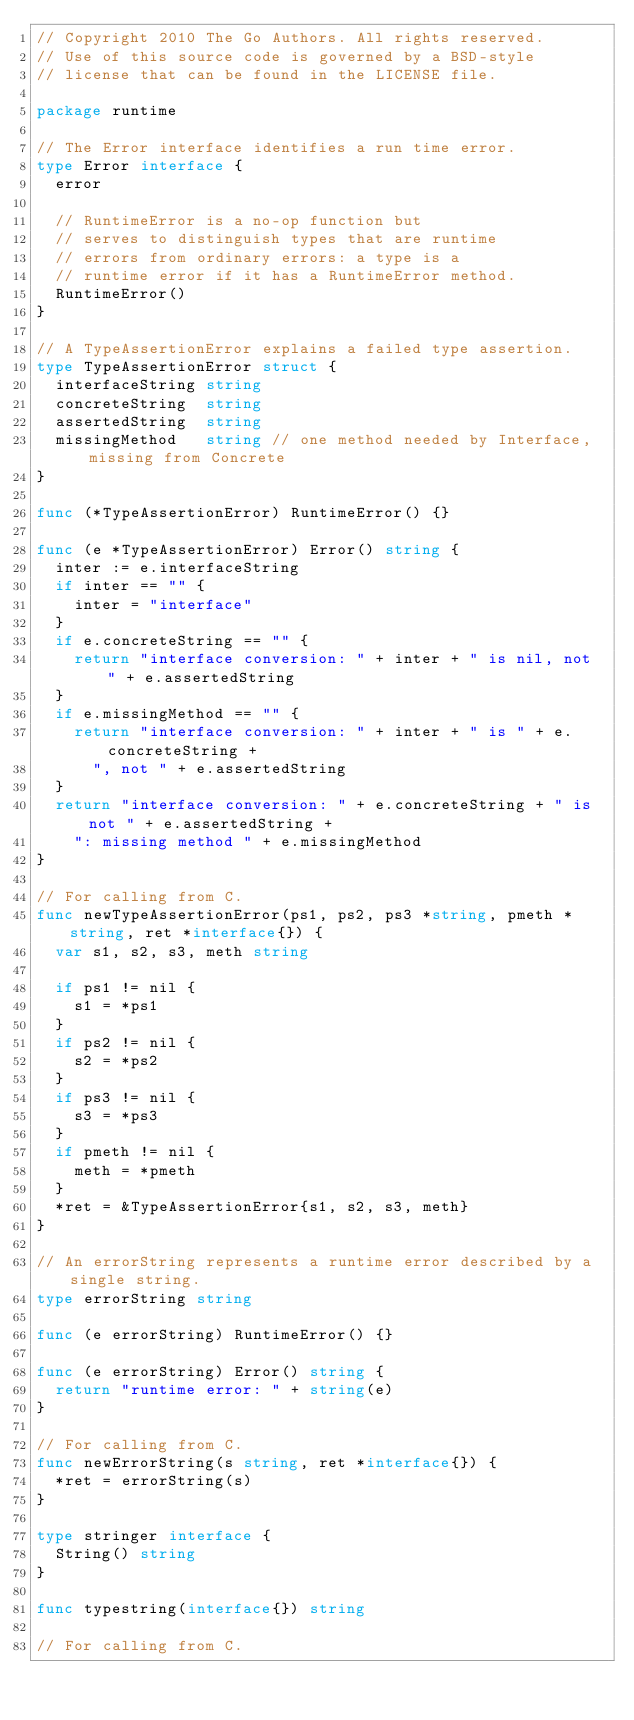<code> <loc_0><loc_0><loc_500><loc_500><_Go_>// Copyright 2010 The Go Authors. All rights reserved.
// Use of this source code is governed by a BSD-style
// license that can be found in the LICENSE file.

package runtime

// The Error interface identifies a run time error.
type Error interface {
	error

	// RuntimeError is a no-op function but
	// serves to distinguish types that are runtime
	// errors from ordinary errors: a type is a
	// runtime error if it has a RuntimeError method.
	RuntimeError()
}

// A TypeAssertionError explains a failed type assertion.
type TypeAssertionError struct {
	interfaceString string
	concreteString  string
	assertedString  string
	missingMethod   string // one method needed by Interface, missing from Concrete
}

func (*TypeAssertionError) RuntimeError() {}

func (e *TypeAssertionError) Error() string {
	inter := e.interfaceString
	if inter == "" {
		inter = "interface"
	}
	if e.concreteString == "" {
		return "interface conversion: " + inter + " is nil, not " + e.assertedString
	}
	if e.missingMethod == "" {
		return "interface conversion: " + inter + " is " + e.concreteString +
			", not " + e.assertedString
	}
	return "interface conversion: " + e.concreteString + " is not " + e.assertedString +
		": missing method " + e.missingMethod
}

// For calling from C.
func newTypeAssertionError(ps1, ps2, ps3 *string, pmeth *string, ret *interface{}) {
	var s1, s2, s3, meth string

	if ps1 != nil {
		s1 = *ps1
	}
	if ps2 != nil {
		s2 = *ps2
	}
	if ps3 != nil {
		s3 = *ps3
	}
	if pmeth != nil {
		meth = *pmeth
	}
	*ret = &TypeAssertionError{s1, s2, s3, meth}
}

// An errorString represents a runtime error described by a single string.
type errorString string

func (e errorString) RuntimeError() {}

func (e errorString) Error() string {
	return "runtime error: " + string(e)
}

// For calling from C.
func newErrorString(s string, ret *interface{}) {
	*ret = errorString(s)
}

type stringer interface {
	String() string
}

func typestring(interface{}) string

// For calling from C.</code> 